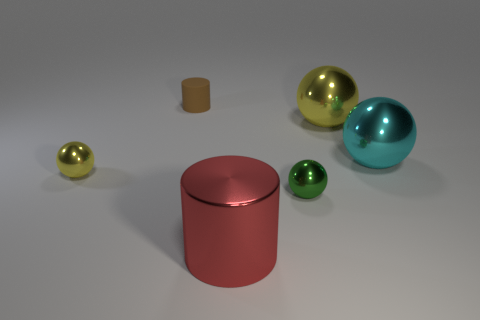Add 4 big red rubber things. How many objects exist? 10 Subtract all cyan spheres. How many spheres are left? 3 Subtract 1 cylinders. How many cylinders are left? 1 Add 6 large yellow metal balls. How many large yellow metal balls are left? 7 Add 1 gray matte cylinders. How many gray matte cylinders exist? 1 Subtract all green spheres. How many spheres are left? 3 Subtract 1 brown cylinders. How many objects are left? 5 Subtract all balls. How many objects are left? 2 Subtract all yellow spheres. Subtract all gray cylinders. How many spheres are left? 2 Subtract all blue blocks. How many brown spheres are left? 0 